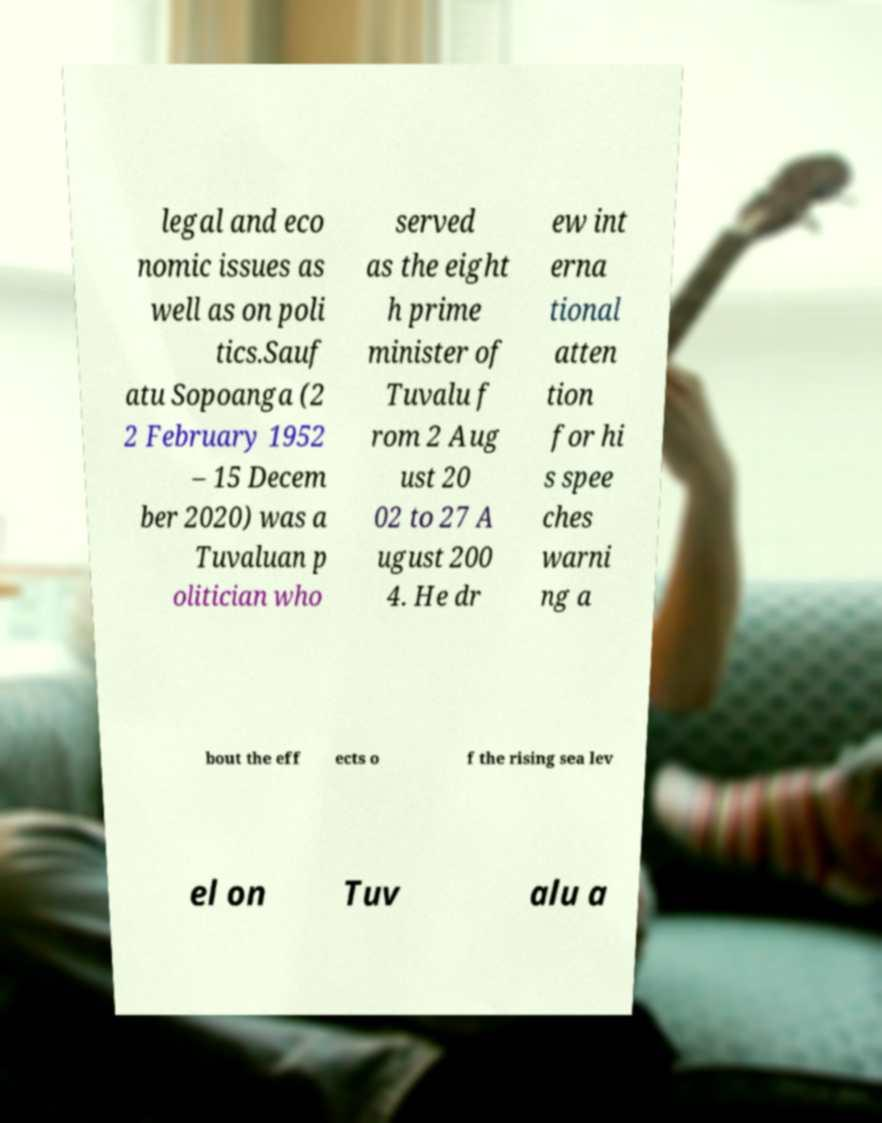What messages or text are displayed in this image? I need them in a readable, typed format. legal and eco nomic issues as well as on poli tics.Sauf atu Sopoanga (2 2 February 1952 – 15 Decem ber 2020) was a Tuvaluan p olitician who served as the eight h prime minister of Tuvalu f rom 2 Aug ust 20 02 to 27 A ugust 200 4. He dr ew int erna tional atten tion for hi s spee ches warni ng a bout the eff ects o f the rising sea lev el on Tuv alu a 